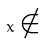<formula> <loc_0><loc_0><loc_500><loc_500>x \notin</formula> 